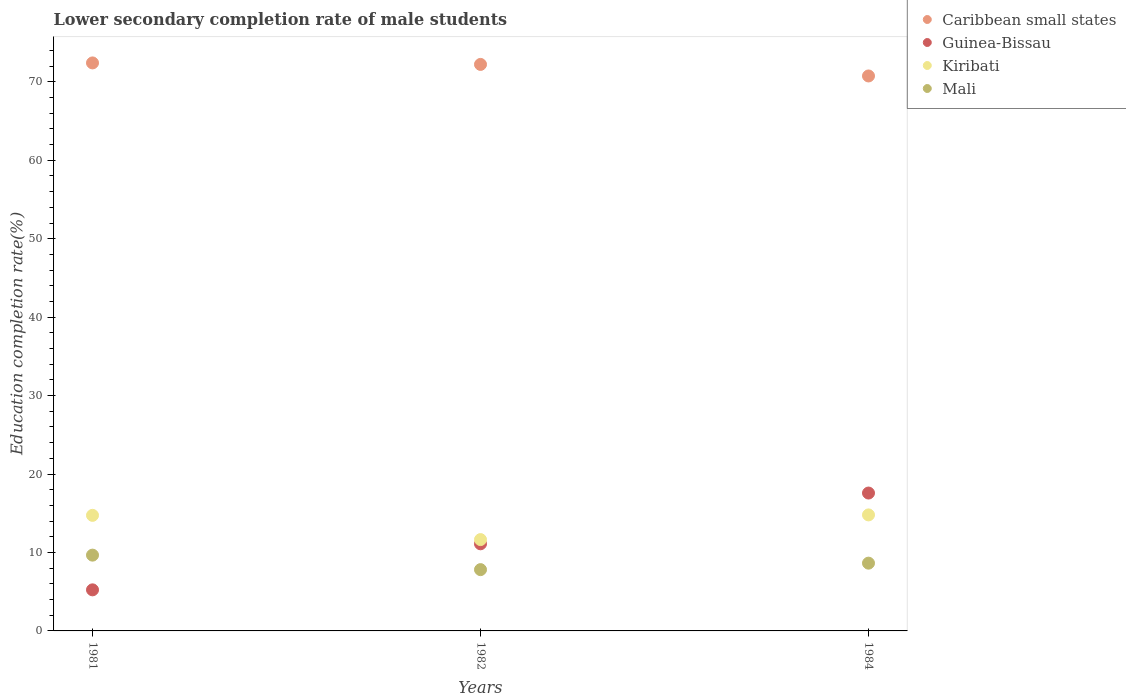Is the number of dotlines equal to the number of legend labels?
Provide a succinct answer. Yes. What is the lower secondary completion rate of male students in Mali in 1984?
Make the answer very short. 8.64. Across all years, what is the maximum lower secondary completion rate of male students in Mali?
Provide a short and direct response. 9.66. Across all years, what is the minimum lower secondary completion rate of male students in Kiribati?
Offer a very short reply. 11.64. In which year was the lower secondary completion rate of male students in Guinea-Bissau maximum?
Provide a short and direct response. 1984. In which year was the lower secondary completion rate of male students in Mali minimum?
Your answer should be very brief. 1982. What is the total lower secondary completion rate of male students in Mali in the graph?
Offer a very short reply. 26.11. What is the difference between the lower secondary completion rate of male students in Guinea-Bissau in 1982 and that in 1984?
Your response must be concise. -6.47. What is the difference between the lower secondary completion rate of male students in Kiribati in 1981 and the lower secondary completion rate of male students in Guinea-Bissau in 1982?
Provide a succinct answer. 3.63. What is the average lower secondary completion rate of male students in Kiribati per year?
Your response must be concise. 13.72. In the year 1982, what is the difference between the lower secondary completion rate of male students in Mali and lower secondary completion rate of male students in Caribbean small states?
Give a very brief answer. -64.41. In how many years, is the lower secondary completion rate of male students in Caribbean small states greater than 32 %?
Keep it short and to the point. 3. What is the ratio of the lower secondary completion rate of male students in Caribbean small states in 1981 to that in 1982?
Give a very brief answer. 1. Is the lower secondary completion rate of male students in Guinea-Bissau in 1981 less than that in 1984?
Make the answer very short. Yes. Is the difference between the lower secondary completion rate of male students in Mali in 1981 and 1982 greater than the difference between the lower secondary completion rate of male students in Caribbean small states in 1981 and 1982?
Your answer should be compact. Yes. What is the difference between the highest and the second highest lower secondary completion rate of male students in Mali?
Offer a very short reply. 1.02. What is the difference between the highest and the lowest lower secondary completion rate of male students in Caribbean small states?
Offer a very short reply. 1.66. Is it the case that in every year, the sum of the lower secondary completion rate of male students in Caribbean small states and lower secondary completion rate of male students in Kiribati  is greater than the sum of lower secondary completion rate of male students in Guinea-Bissau and lower secondary completion rate of male students in Mali?
Your answer should be compact. No. Is the lower secondary completion rate of male students in Mali strictly greater than the lower secondary completion rate of male students in Caribbean small states over the years?
Offer a very short reply. No. Is the lower secondary completion rate of male students in Guinea-Bissau strictly less than the lower secondary completion rate of male students in Caribbean small states over the years?
Keep it short and to the point. Yes. How many dotlines are there?
Your response must be concise. 4. What is the difference between two consecutive major ticks on the Y-axis?
Your answer should be very brief. 10. Does the graph contain any zero values?
Provide a succinct answer. No. Where does the legend appear in the graph?
Provide a succinct answer. Top right. What is the title of the graph?
Ensure brevity in your answer.  Lower secondary completion rate of male students. Does "Small states" appear as one of the legend labels in the graph?
Give a very brief answer. No. What is the label or title of the X-axis?
Provide a short and direct response. Years. What is the label or title of the Y-axis?
Your answer should be very brief. Education completion rate(%). What is the Education completion rate(%) in Caribbean small states in 1981?
Provide a short and direct response. 72.41. What is the Education completion rate(%) of Guinea-Bissau in 1981?
Your answer should be compact. 5.24. What is the Education completion rate(%) in Kiribati in 1981?
Your answer should be very brief. 14.73. What is the Education completion rate(%) of Mali in 1981?
Your response must be concise. 9.66. What is the Education completion rate(%) in Caribbean small states in 1982?
Offer a terse response. 72.22. What is the Education completion rate(%) of Guinea-Bissau in 1982?
Ensure brevity in your answer.  11.11. What is the Education completion rate(%) in Kiribati in 1982?
Ensure brevity in your answer.  11.64. What is the Education completion rate(%) in Mali in 1982?
Keep it short and to the point. 7.81. What is the Education completion rate(%) of Caribbean small states in 1984?
Provide a short and direct response. 70.75. What is the Education completion rate(%) in Guinea-Bissau in 1984?
Provide a succinct answer. 17.58. What is the Education completion rate(%) in Kiribati in 1984?
Keep it short and to the point. 14.79. What is the Education completion rate(%) of Mali in 1984?
Your answer should be compact. 8.64. Across all years, what is the maximum Education completion rate(%) in Caribbean small states?
Provide a short and direct response. 72.41. Across all years, what is the maximum Education completion rate(%) of Guinea-Bissau?
Give a very brief answer. 17.58. Across all years, what is the maximum Education completion rate(%) of Kiribati?
Provide a succinct answer. 14.79. Across all years, what is the maximum Education completion rate(%) of Mali?
Your answer should be compact. 9.66. Across all years, what is the minimum Education completion rate(%) of Caribbean small states?
Your answer should be very brief. 70.75. Across all years, what is the minimum Education completion rate(%) in Guinea-Bissau?
Offer a very short reply. 5.24. Across all years, what is the minimum Education completion rate(%) of Kiribati?
Ensure brevity in your answer.  11.64. Across all years, what is the minimum Education completion rate(%) of Mali?
Provide a succinct answer. 7.81. What is the total Education completion rate(%) in Caribbean small states in the graph?
Provide a short and direct response. 215.38. What is the total Education completion rate(%) of Guinea-Bissau in the graph?
Give a very brief answer. 33.92. What is the total Education completion rate(%) of Kiribati in the graph?
Make the answer very short. 41.17. What is the total Education completion rate(%) of Mali in the graph?
Make the answer very short. 26.11. What is the difference between the Education completion rate(%) of Caribbean small states in 1981 and that in 1982?
Make the answer very short. 0.19. What is the difference between the Education completion rate(%) of Guinea-Bissau in 1981 and that in 1982?
Offer a very short reply. -5.87. What is the difference between the Education completion rate(%) in Kiribati in 1981 and that in 1982?
Provide a succinct answer. 3.09. What is the difference between the Education completion rate(%) in Mali in 1981 and that in 1982?
Offer a very short reply. 1.85. What is the difference between the Education completion rate(%) in Caribbean small states in 1981 and that in 1984?
Ensure brevity in your answer.  1.66. What is the difference between the Education completion rate(%) in Guinea-Bissau in 1981 and that in 1984?
Keep it short and to the point. -12.34. What is the difference between the Education completion rate(%) in Kiribati in 1981 and that in 1984?
Offer a very short reply. -0.06. What is the difference between the Education completion rate(%) in Mali in 1981 and that in 1984?
Ensure brevity in your answer.  1.02. What is the difference between the Education completion rate(%) in Caribbean small states in 1982 and that in 1984?
Ensure brevity in your answer.  1.47. What is the difference between the Education completion rate(%) of Guinea-Bissau in 1982 and that in 1984?
Your answer should be very brief. -6.47. What is the difference between the Education completion rate(%) in Kiribati in 1982 and that in 1984?
Your answer should be compact. -3.15. What is the difference between the Education completion rate(%) in Mali in 1982 and that in 1984?
Keep it short and to the point. -0.83. What is the difference between the Education completion rate(%) in Caribbean small states in 1981 and the Education completion rate(%) in Guinea-Bissau in 1982?
Your answer should be compact. 61.31. What is the difference between the Education completion rate(%) of Caribbean small states in 1981 and the Education completion rate(%) of Kiribati in 1982?
Provide a succinct answer. 60.77. What is the difference between the Education completion rate(%) in Caribbean small states in 1981 and the Education completion rate(%) in Mali in 1982?
Keep it short and to the point. 64.6. What is the difference between the Education completion rate(%) in Guinea-Bissau in 1981 and the Education completion rate(%) in Kiribati in 1982?
Make the answer very short. -6.41. What is the difference between the Education completion rate(%) of Guinea-Bissau in 1981 and the Education completion rate(%) of Mali in 1982?
Your response must be concise. -2.58. What is the difference between the Education completion rate(%) of Kiribati in 1981 and the Education completion rate(%) of Mali in 1982?
Provide a succinct answer. 6.92. What is the difference between the Education completion rate(%) in Caribbean small states in 1981 and the Education completion rate(%) in Guinea-Bissau in 1984?
Provide a short and direct response. 54.84. What is the difference between the Education completion rate(%) of Caribbean small states in 1981 and the Education completion rate(%) of Kiribati in 1984?
Your answer should be compact. 57.62. What is the difference between the Education completion rate(%) of Caribbean small states in 1981 and the Education completion rate(%) of Mali in 1984?
Your response must be concise. 63.77. What is the difference between the Education completion rate(%) of Guinea-Bissau in 1981 and the Education completion rate(%) of Kiribati in 1984?
Make the answer very short. -9.55. What is the difference between the Education completion rate(%) in Guinea-Bissau in 1981 and the Education completion rate(%) in Mali in 1984?
Offer a terse response. -3.4. What is the difference between the Education completion rate(%) in Kiribati in 1981 and the Education completion rate(%) in Mali in 1984?
Provide a succinct answer. 6.09. What is the difference between the Education completion rate(%) in Caribbean small states in 1982 and the Education completion rate(%) in Guinea-Bissau in 1984?
Give a very brief answer. 54.64. What is the difference between the Education completion rate(%) of Caribbean small states in 1982 and the Education completion rate(%) of Kiribati in 1984?
Provide a short and direct response. 57.43. What is the difference between the Education completion rate(%) of Caribbean small states in 1982 and the Education completion rate(%) of Mali in 1984?
Ensure brevity in your answer.  63.58. What is the difference between the Education completion rate(%) of Guinea-Bissau in 1982 and the Education completion rate(%) of Kiribati in 1984?
Provide a short and direct response. -3.68. What is the difference between the Education completion rate(%) of Guinea-Bissau in 1982 and the Education completion rate(%) of Mali in 1984?
Provide a short and direct response. 2.47. What is the difference between the Education completion rate(%) of Kiribati in 1982 and the Education completion rate(%) of Mali in 1984?
Your answer should be very brief. 3. What is the average Education completion rate(%) in Caribbean small states per year?
Make the answer very short. 71.79. What is the average Education completion rate(%) of Guinea-Bissau per year?
Offer a terse response. 11.31. What is the average Education completion rate(%) of Kiribati per year?
Give a very brief answer. 13.72. What is the average Education completion rate(%) in Mali per year?
Give a very brief answer. 8.7. In the year 1981, what is the difference between the Education completion rate(%) in Caribbean small states and Education completion rate(%) in Guinea-Bissau?
Offer a terse response. 67.18. In the year 1981, what is the difference between the Education completion rate(%) in Caribbean small states and Education completion rate(%) in Kiribati?
Your answer should be compact. 57.68. In the year 1981, what is the difference between the Education completion rate(%) in Caribbean small states and Education completion rate(%) in Mali?
Your response must be concise. 62.75. In the year 1981, what is the difference between the Education completion rate(%) in Guinea-Bissau and Education completion rate(%) in Kiribati?
Make the answer very short. -9.5. In the year 1981, what is the difference between the Education completion rate(%) in Guinea-Bissau and Education completion rate(%) in Mali?
Your answer should be compact. -4.42. In the year 1981, what is the difference between the Education completion rate(%) of Kiribati and Education completion rate(%) of Mali?
Your answer should be very brief. 5.07. In the year 1982, what is the difference between the Education completion rate(%) in Caribbean small states and Education completion rate(%) in Guinea-Bissau?
Provide a succinct answer. 61.12. In the year 1982, what is the difference between the Education completion rate(%) of Caribbean small states and Education completion rate(%) of Kiribati?
Offer a very short reply. 60.58. In the year 1982, what is the difference between the Education completion rate(%) in Caribbean small states and Education completion rate(%) in Mali?
Ensure brevity in your answer.  64.41. In the year 1982, what is the difference between the Education completion rate(%) in Guinea-Bissau and Education completion rate(%) in Kiribati?
Your answer should be very brief. -0.54. In the year 1982, what is the difference between the Education completion rate(%) of Guinea-Bissau and Education completion rate(%) of Mali?
Your answer should be very brief. 3.29. In the year 1982, what is the difference between the Education completion rate(%) in Kiribati and Education completion rate(%) in Mali?
Ensure brevity in your answer.  3.83. In the year 1984, what is the difference between the Education completion rate(%) in Caribbean small states and Education completion rate(%) in Guinea-Bissau?
Provide a short and direct response. 53.17. In the year 1984, what is the difference between the Education completion rate(%) in Caribbean small states and Education completion rate(%) in Kiribati?
Keep it short and to the point. 55.96. In the year 1984, what is the difference between the Education completion rate(%) in Caribbean small states and Education completion rate(%) in Mali?
Keep it short and to the point. 62.11. In the year 1984, what is the difference between the Education completion rate(%) in Guinea-Bissau and Education completion rate(%) in Kiribati?
Make the answer very short. 2.79. In the year 1984, what is the difference between the Education completion rate(%) of Guinea-Bissau and Education completion rate(%) of Mali?
Provide a short and direct response. 8.94. In the year 1984, what is the difference between the Education completion rate(%) of Kiribati and Education completion rate(%) of Mali?
Give a very brief answer. 6.15. What is the ratio of the Education completion rate(%) of Caribbean small states in 1981 to that in 1982?
Make the answer very short. 1. What is the ratio of the Education completion rate(%) in Guinea-Bissau in 1981 to that in 1982?
Your answer should be compact. 0.47. What is the ratio of the Education completion rate(%) of Kiribati in 1981 to that in 1982?
Your answer should be compact. 1.27. What is the ratio of the Education completion rate(%) in Mali in 1981 to that in 1982?
Ensure brevity in your answer.  1.24. What is the ratio of the Education completion rate(%) of Caribbean small states in 1981 to that in 1984?
Offer a terse response. 1.02. What is the ratio of the Education completion rate(%) in Guinea-Bissau in 1981 to that in 1984?
Ensure brevity in your answer.  0.3. What is the ratio of the Education completion rate(%) in Kiribati in 1981 to that in 1984?
Your response must be concise. 1. What is the ratio of the Education completion rate(%) of Mali in 1981 to that in 1984?
Offer a terse response. 1.12. What is the ratio of the Education completion rate(%) of Caribbean small states in 1982 to that in 1984?
Provide a succinct answer. 1.02. What is the ratio of the Education completion rate(%) of Guinea-Bissau in 1982 to that in 1984?
Give a very brief answer. 0.63. What is the ratio of the Education completion rate(%) of Kiribati in 1982 to that in 1984?
Give a very brief answer. 0.79. What is the ratio of the Education completion rate(%) in Mali in 1982 to that in 1984?
Provide a short and direct response. 0.9. What is the difference between the highest and the second highest Education completion rate(%) of Caribbean small states?
Make the answer very short. 0.19. What is the difference between the highest and the second highest Education completion rate(%) in Guinea-Bissau?
Keep it short and to the point. 6.47. What is the difference between the highest and the second highest Education completion rate(%) in Kiribati?
Provide a succinct answer. 0.06. What is the difference between the highest and the second highest Education completion rate(%) of Mali?
Keep it short and to the point. 1.02. What is the difference between the highest and the lowest Education completion rate(%) in Caribbean small states?
Your response must be concise. 1.66. What is the difference between the highest and the lowest Education completion rate(%) in Guinea-Bissau?
Your answer should be very brief. 12.34. What is the difference between the highest and the lowest Education completion rate(%) in Kiribati?
Your response must be concise. 3.15. What is the difference between the highest and the lowest Education completion rate(%) of Mali?
Provide a succinct answer. 1.85. 